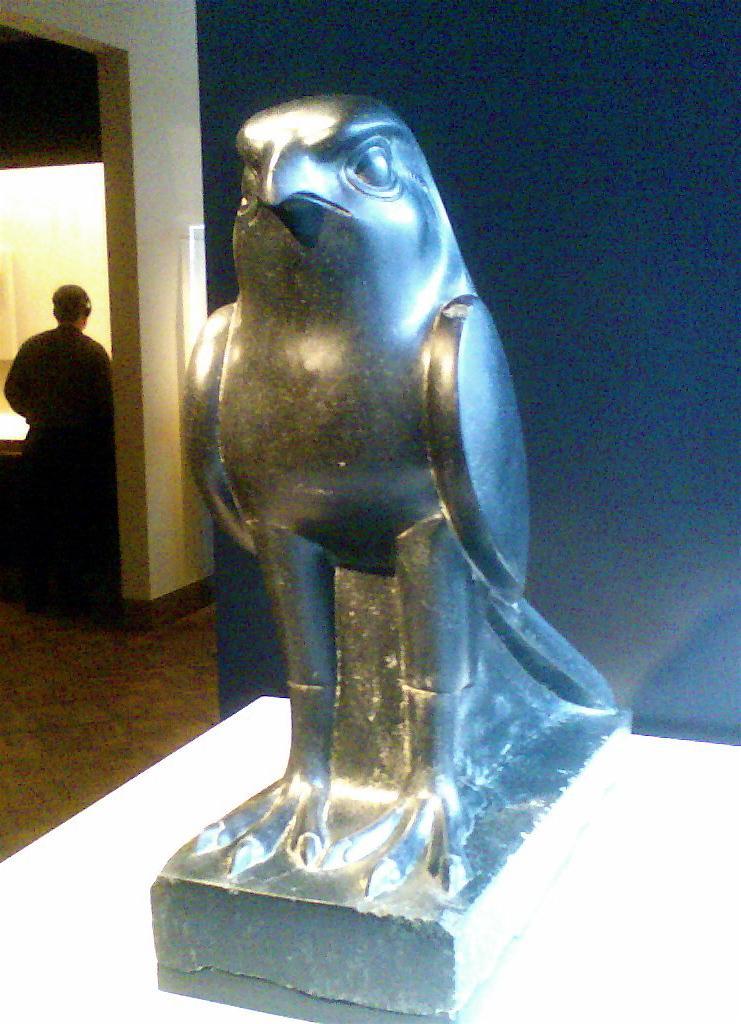How would you summarize this image in a sentence or two? In this image I can see a black colored statue of a bird on the white colored surface. In the background I can see the wall, a person standing and a light. 